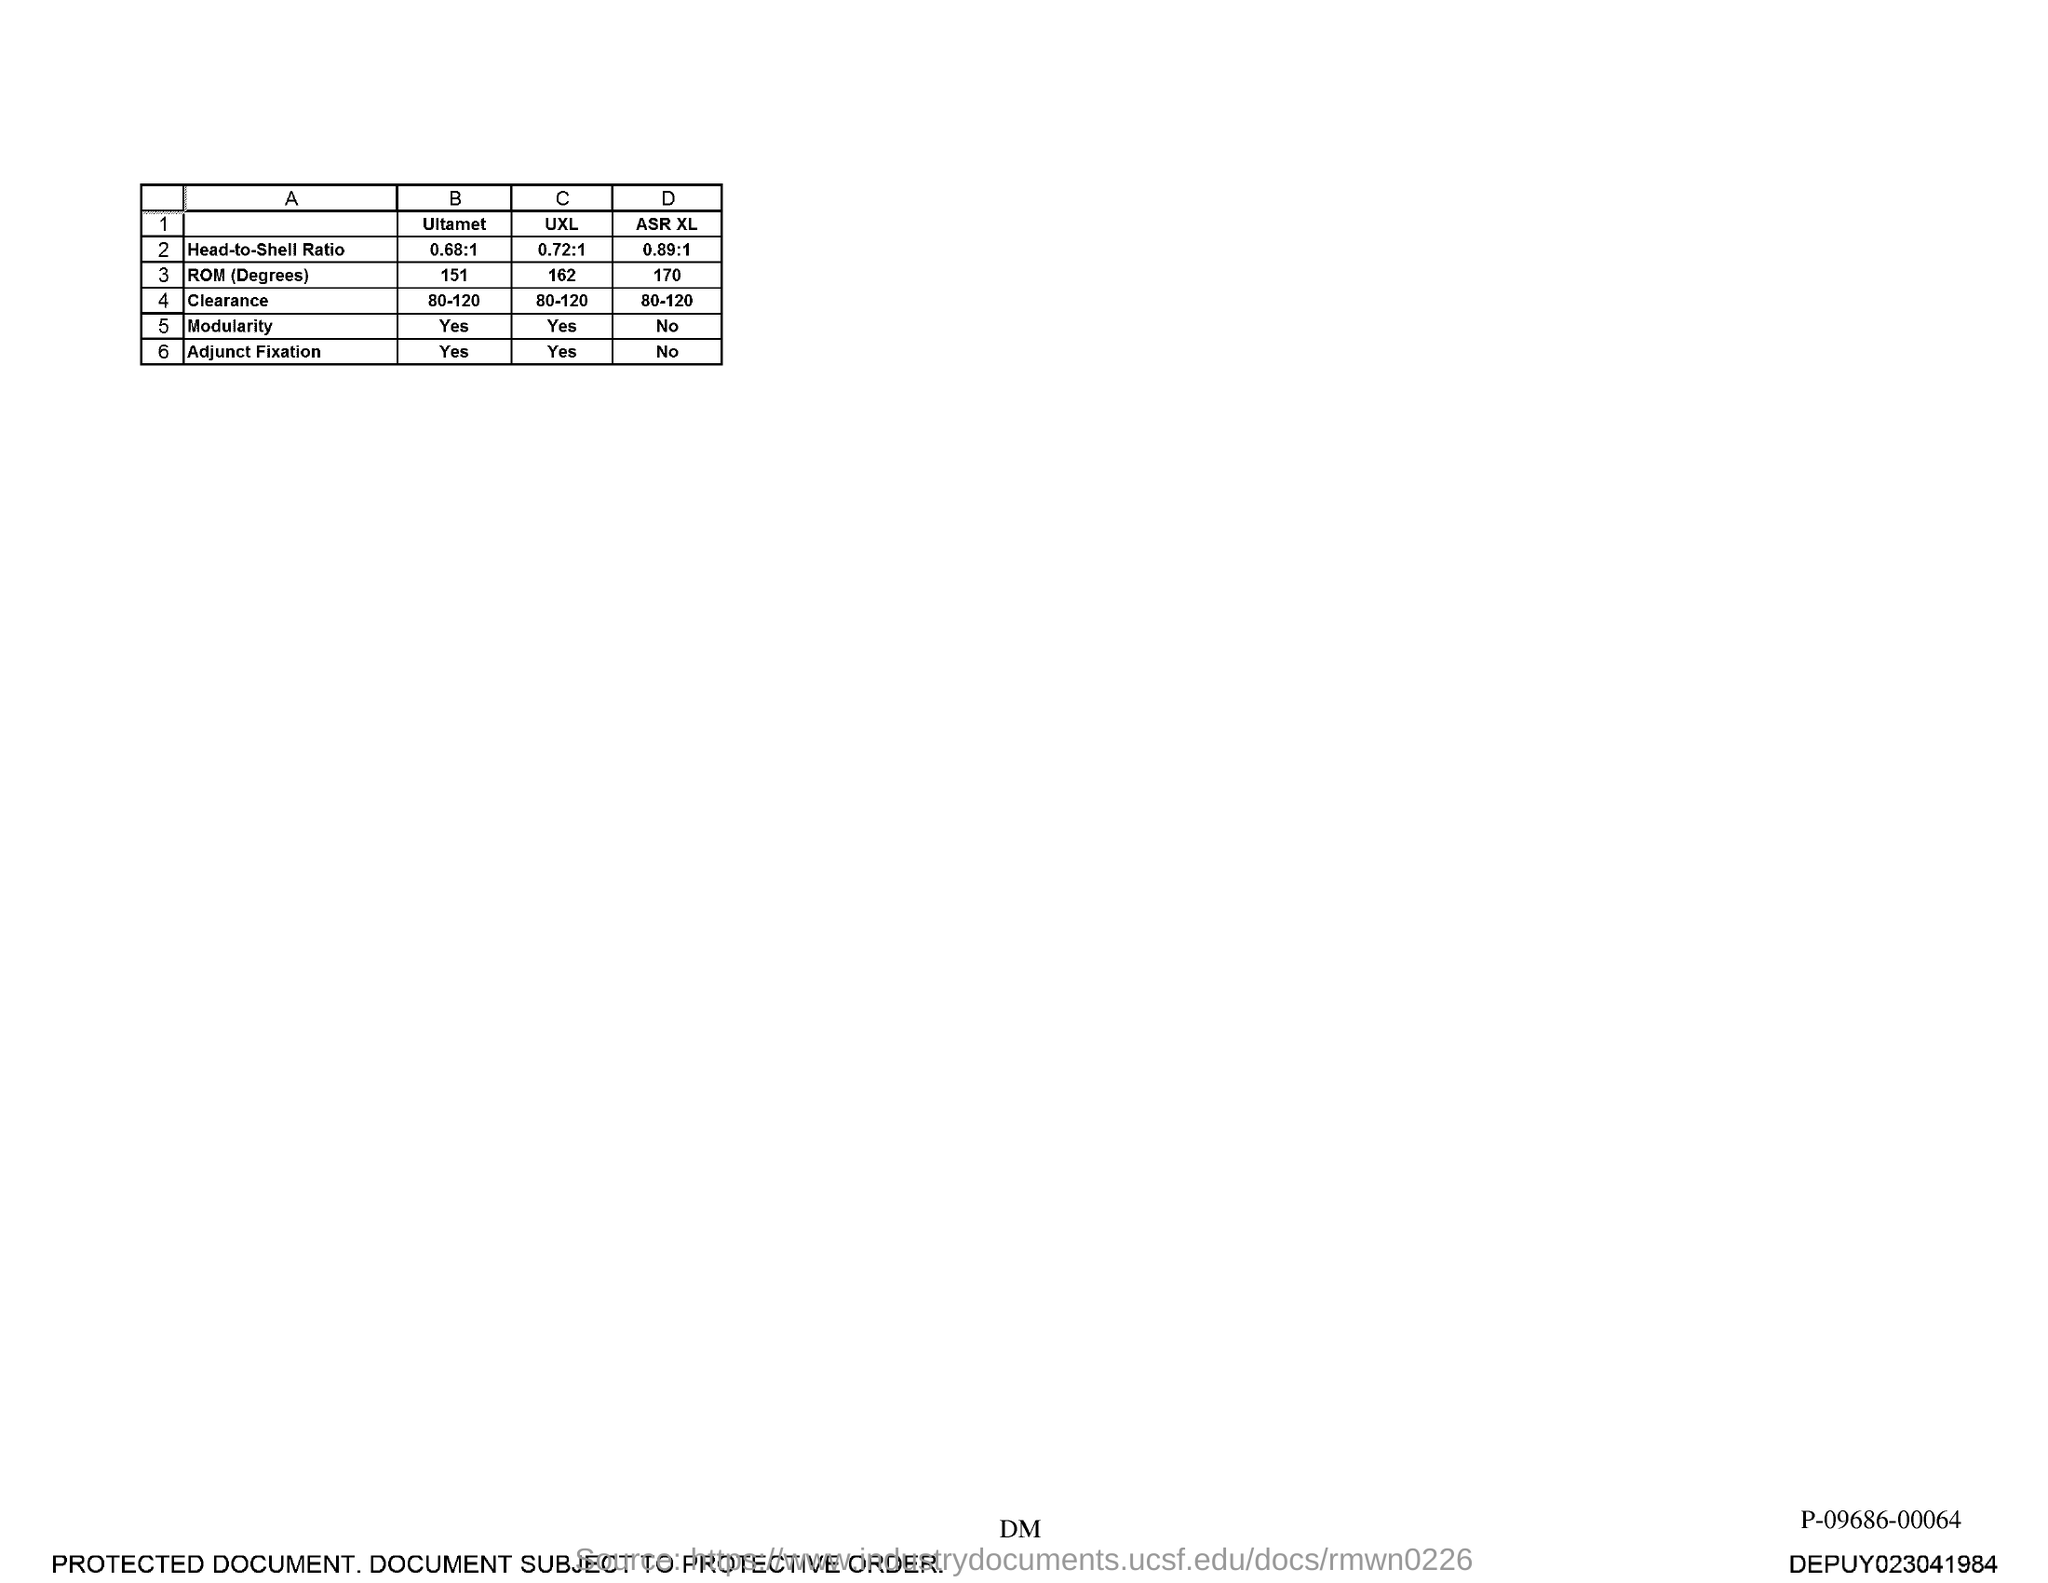Point out several critical features in this image. The head-to-shell ratio of Ultamet is 0.68:1, indicating that for every 0.68 parts of metal powder in the shell, there is 1 part of metal powder in the head. The head-to-shell ratio of UXL is 0.72:1, which indicates that for every dollar of revenue generated by UXL, 72 cents is allocated to the shell, which represents the operating costs and expenses of the company. 